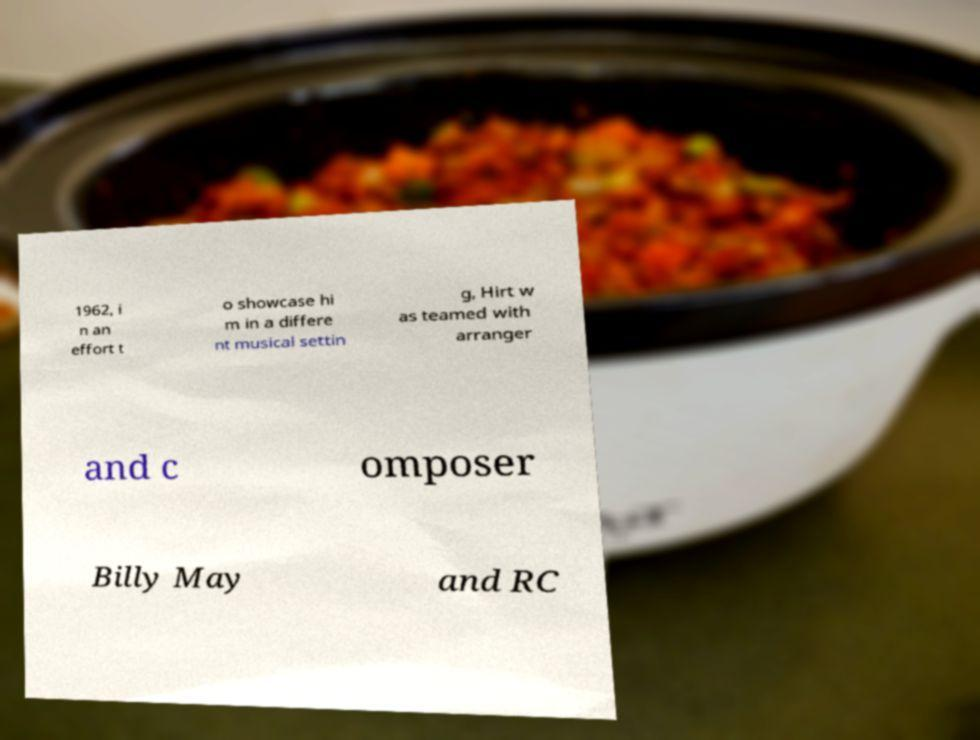I need the written content from this picture converted into text. Can you do that? 1962, i n an effort t o showcase hi m in a differe nt musical settin g, Hirt w as teamed with arranger and c omposer Billy May and RC 